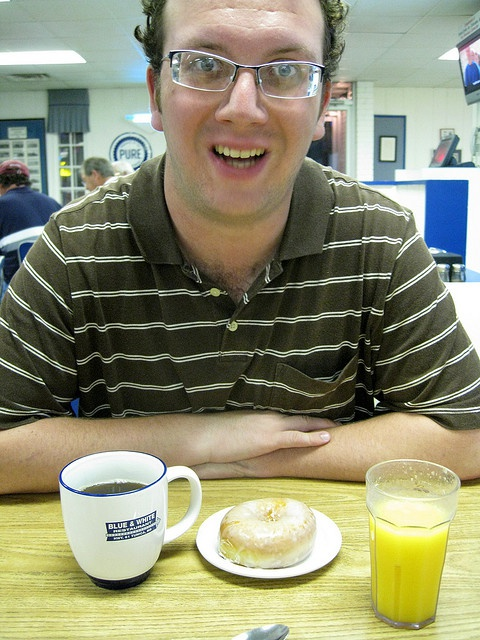Describe the objects in this image and their specific colors. I can see people in white, black, gray, and tan tones, dining table in white, khaki, beige, and tan tones, cup in white, ivory, beige, black, and gray tones, cup in white, gold, khaki, lightyellow, and olive tones, and donut in white, beige, khaki, and tan tones in this image. 